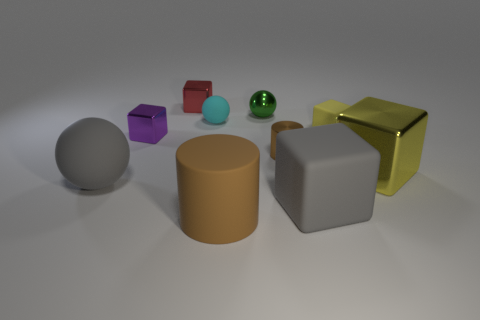What number of objects are either tiny cyan spheres or red matte cylinders?
Your answer should be very brief. 1. Does the matte cylinder that is in front of the tiny brown thing have the same size as the brown object behind the big brown cylinder?
Offer a terse response. No. How many other objects are there of the same material as the small cyan ball?
Offer a terse response. 4. Are there more small green balls that are in front of the gray rubber cube than tiny cubes that are on the left side of the red object?
Give a very brief answer. No. What is the ball that is to the right of the tiny matte sphere made of?
Keep it short and to the point. Metal. Does the big brown thing have the same shape as the yellow shiny object?
Provide a succinct answer. No. Is there any other thing that is the same color as the big metallic cube?
Your answer should be very brief. Yes. What color is the other large thing that is the same shape as the brown shiny object?
Keep it short and to the point. Brown. Is the number of big yellow objects to the left of the green metallic object greater than the number of small blue matte cylinders?
Make the answer very short. No. What color is the ball in front of the brown metal cylinder?
Your answer should be very brief. Gray. 